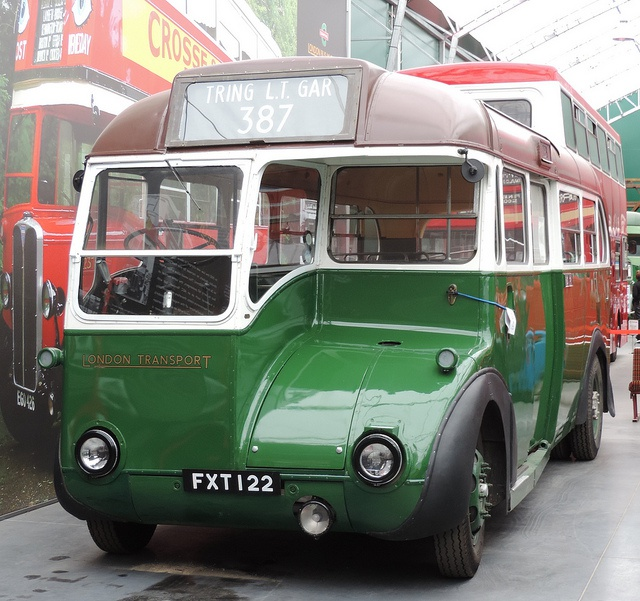Describe the objects in this image and their specific colors. I can see bus in darkgray, black, darkgreen, white, and gray tones, bus in darkgray, ivory, lightpink, and gray tones, and bus in darkgray, white, lightpink, and salmon tones in this image. 